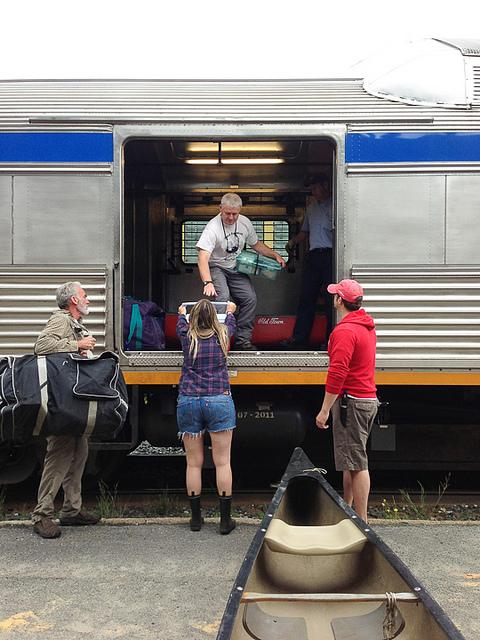What is this type of train car called? passenger 